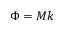<formula> <loc_0><loc_0><loc_500><loc_500>\Phi = M k</formula> 